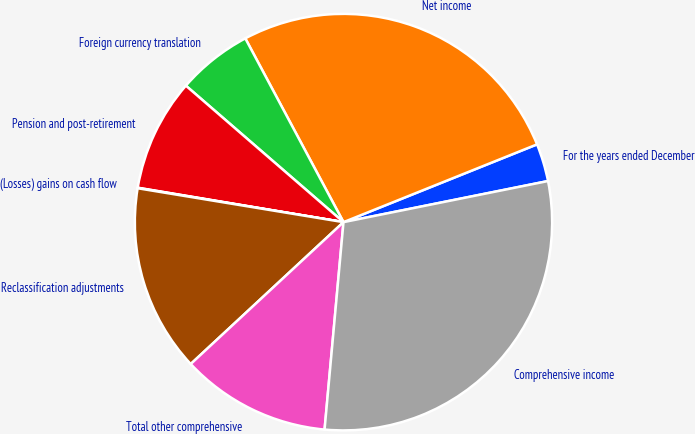Convert chart to OTSL. <chart><loc_0><loc_0><loc_500><loc_500><pie_chart><fcel>For the years ended December<fcel>Net income<fcel>Foreign currency translation<fcel>Pension and post-retirement<fcel>(Losses) gains on cash flow<fcel>Reclassification adjustments<fcel>Total other comprehensive<fcel>Comprehensive income<nl><fcel>2.93%<fcel>26.71%<fcel>5.83%<fcel>8.73%<fcel>0.04%<fcel>14.53%<fcel>11.63%<fcel>29.61%<nl></chart> 